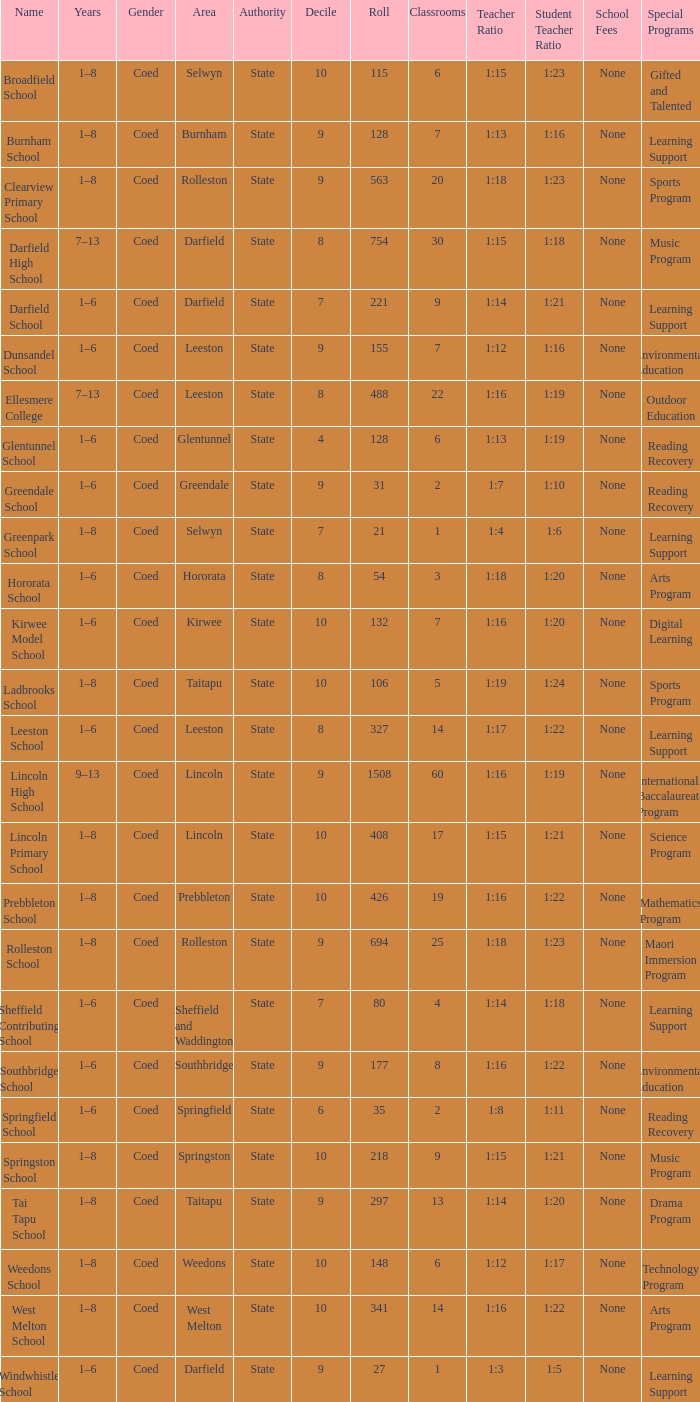Help me parse the entirety of this table. {'header': ['Name', 'Years', 'Gender', 'Area', 'Authority', 'Decile', 'Roll', 'Classrooms', 'Teacher Ratio', 'Student Teacher Ratio', 'School Fees', 'Special Programs '], 'rows': [['Broadfield School', '1–8', 'Coed', 'Selwyn', 'State', '10', '115', '6', '1:15', '1:23', 'None', 'Gifted and Talented '], ['Burnham School', '1–8', 'Coed', 'Burnham', 'State', '9', '128', '7', '1:13', '1:16', 'None', 'Learning Support '], ['Clearview Primary School', '1–8', 'Coed', 'Rolleston', 'State', '9', '563', '20', '1:18', '1:23', 'None', 'Sports Program '], ['Darfield High School', '7–13', 'Coed', 'Darfield', 'State', '8', '754', '30', '1:15', '1:18', 'None', 'Music Program '], ['Darfield School', '1–6', 'Coed', 'Darfield', 'State', '7', '221', '9', '1:14', '1:21', 'None', 'Learning Support '], ['Dunsandel School', '1–6', 'Coed', 'Leeston', 'State', '9', '155', '7', '1:12', '1:16', 'None', 'Environmental Education '], ['Ellesmere College', '7–13', 'Coed', 'Leeston', 'State', '8', '488', '22', '1:16', '1:19', 'None', 'Outdoor Education '], ['Glentunnel School', '1–6', 'Coed', 'Glentunnel', 'State', '4', '128', '6', '1:13', '1:19', 'None', 'Reading Recovery '], ['Greendale School', '1–6', 'Coed', 'Greendale', 'State', '9', '31', '2', '1:7', '1:10', 'None', 'Reading Recovery '], ['Greenpark School', '1–8', 'Coed', 'Selwyn', 'State', '7', '21', '1', '1:4', '1:6', 'None', 'Learning Support '], ['Hororata School', '1–6', 'Coed', 'Hororata', 'State', '8', '54', '3', '1:18', '1:20', 'None', 'Arts Program '], ['Kirwee Model School', '1–6', 'Coed', 'Kirwee', 'State', '10', '132', '7', '1:16', '1:20', 'None', 'Digital Learning '], ['Ladbrooks School', '1–8', 'Coed', 'Taitapu', 'State', '10', '106', '5', '1:19', '1:24', 'None', 'Sports Program '], ['Leeston School', '1–6', 'Coed', 'Leeston', 'State', '8', '327', '14', '1:17', '1:22', 'None', 'Learning Support '], ['Lincoln High School', '9–13', 'Coed', 'Lincoln', 'State', '9', '1508', '60', '1:16', '1:19', 'None', 'International Baccalaureate Program '], ['Lincoln Primary School', '1–8', 'Coed', 'Lincoln', 'State', '10', '408', '17', '1:15', '1:21', 'None', 'Science Program '], ['Prebbleton School', '1–8', 'Coed', 'Prebbleton', 'State', '10', '426', '19', '1:16', '1:22', 'None', 'Mathematics Program '], ['Rolleston School', '1–8', 'Coed', 'Rolleston', 'State', '9', '694', '25', '1:18', '1:23', 'None', 'Maori Immersion Program '], ['Sheffield Contributing School', '1–6', 'Coed', 'Sheffield and Waddington', 'State', '7', '80', '4', '1:14', '1:18', 'None', 'Learning Support '], ['Southbridge School', '1–6', 'Coed', 'Southbridge', 'State', '9', '177', '8', '1:16', '1:22', 'None', 'Environmental Education '], ['Springfield School', '1–6', 'Coed', 'Springfield', 'State', '6', '35', '2', '1:8', '1:11', 'None', 'Reading Recovery '], ['Springston School', '1–8', 'Coed', 'Springston', 'State', '10', '218', '9', '1:15', '1:21', 'None', 'Music Program '], ['Tai Tapu School', '1–8', 'Coed', 'Taitapu', 'State', '9', '297', '13', '1:14', '1:20', 'None', 'Drama Program '], ['Weedons School', '1–8', 'Coed', 'Weedons', 'State', '10', '148', '6', '1:12', '1:17', 'None', 'Technology Program '], ['West Melton School', '1–8', 'Coed', 'West Melton', 'State', '10', '341', '14', '1:16', '1:22', 'None', 'Arts Program '], ['Windwhistle School', '1–6', 'Coed', 'Darfield', 'State', '9', '27', '1', '1:3', '1:5', 'None', 'Learning Support']]} Which area has a Decile of 9, and a Roll of 31? Greendale. 